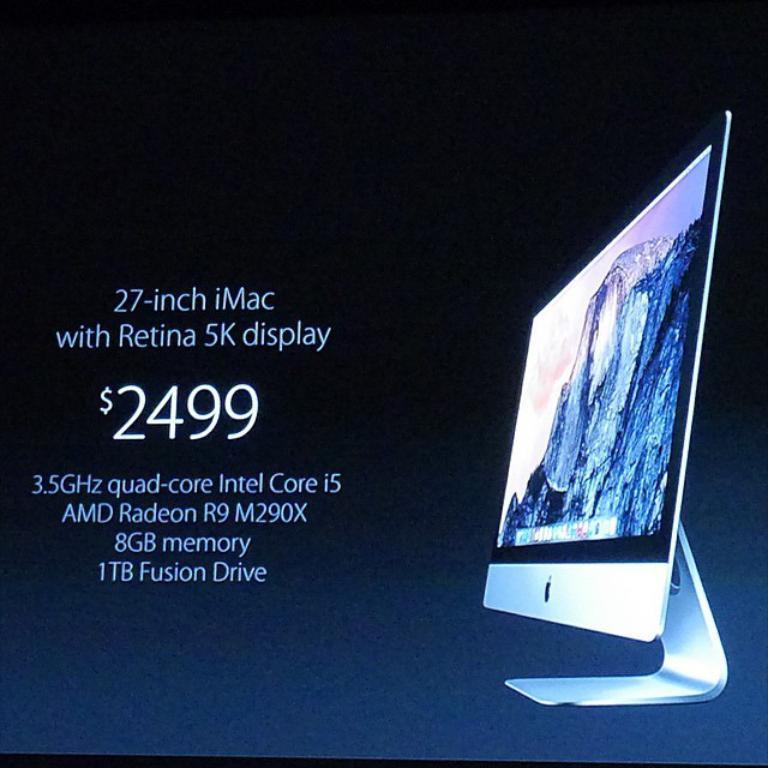<image>
Relay a brief, clear account of the picture shown. An ad for a 27 inch iMac computer with monitor showing 